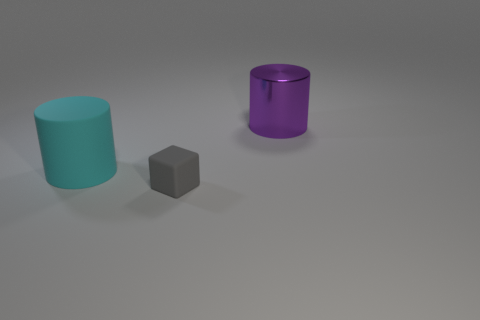Is there anything else that has the same material as the big purple thing?
Provide a succinct answer. No. Do the tiny rubber object and the thing on the right side of the cube have the same color?
Offer a very short reply. No. Are there fewer cyan things than yellow shiny spheres?
Your answer should be very brief. No. How big is the thing that is behind the small gray rubber cube and in front of the big purple thing?
Your response must be concise. Large. Is the color of the tiny rubber block that is left of the big purple object the same as the large shiny cylinder?
Your answer should be compact. No. Are there fewer rubber cubes that are on the left side of the tiny rubber object than gray blocks?
Provide a short and direct response. Yes. What shape is the other large thing that is made of the same material as the gray thing?
Offer a very short reply. Cylinder. Are the tiny gray object and the big cyan thing made of the same material?
Provide a short and direct response. Yes. Is the number of small gray rubber things that are on the right side of the gray matte cube less than the number of cyan matte objects in front of the large cyan object?
Give a very brief answer. No. What number of cubes are to the right of the large thing behind the large cylinder that is in front of the large purple cylinder?
Your answer should be compact. 0. 